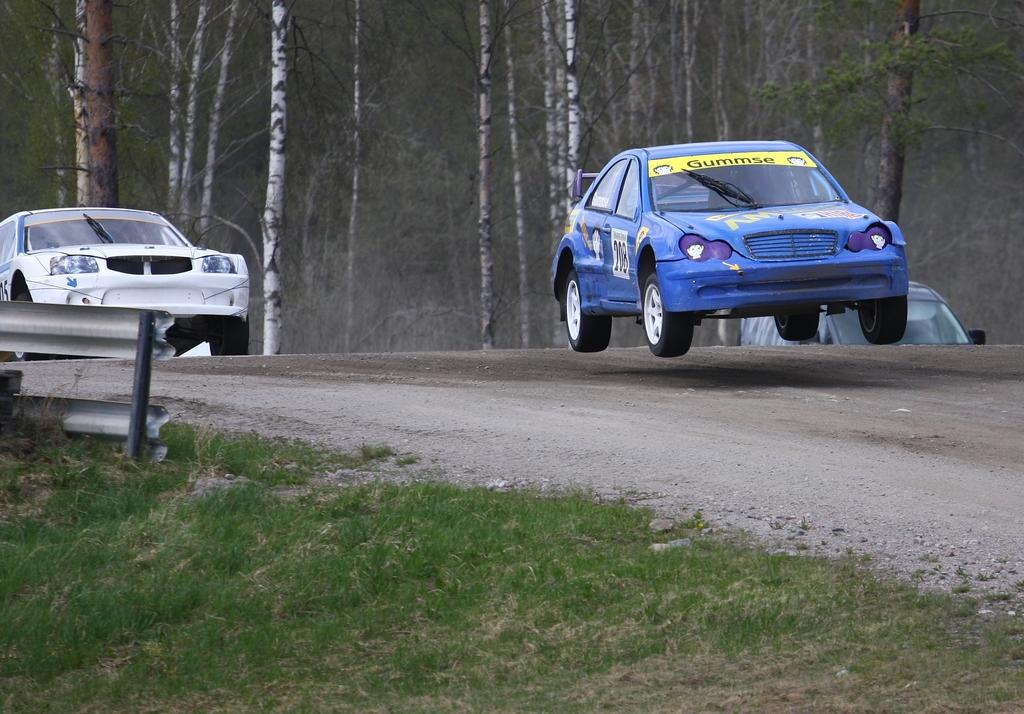What type of vegetation is present in the image? There is grass in the image. What type of man-made structure can be seen in the image? There is a road in the image. What vehicles are on the road? There are cars on the road. What can be seen in the background of the image? There are trees in the background of the image. What type of basketball court can be seen in the image? There is no basketball court present in the image. What is the condition of the grass in the image? The condition of the grass cannot be determined from the image alone. Can you see any steam coming from the cars in the image? There is no steam visible in the image. 